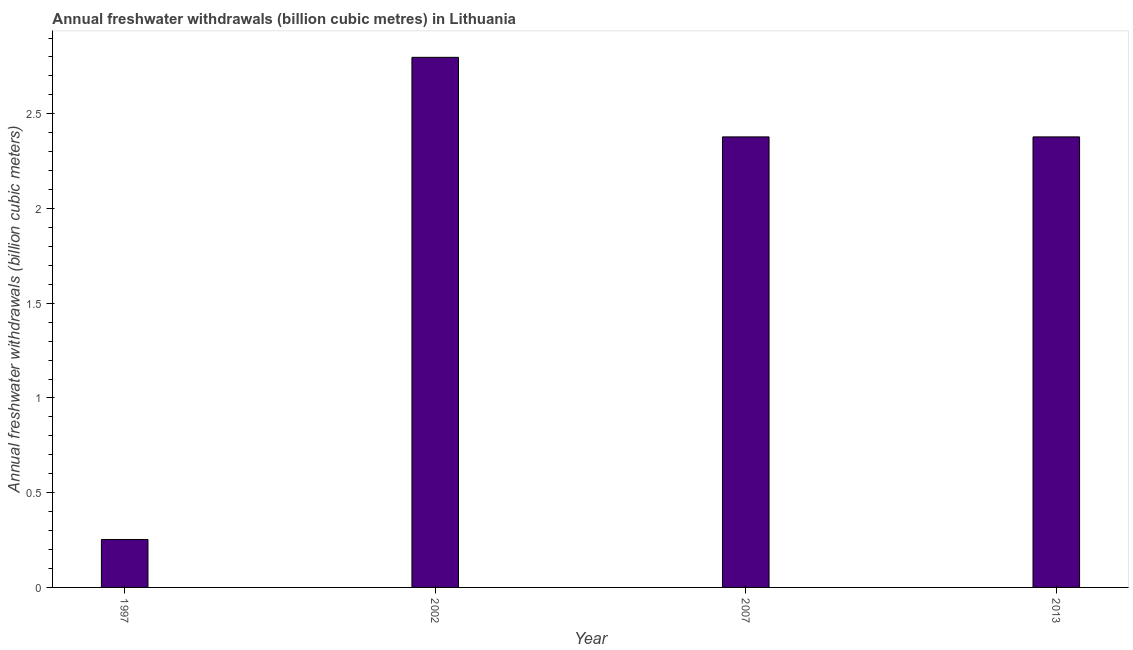Does the graph contain any zero values?
Keep it short and to the point. No. Does the graph contain grids?
Offer a terse response. No. What is the title of the graph?
Your answer should be very brief. Annual freshwater withdrawals (billion cubic metres) in Lithuania. What is the label or title of the X-axis?
Provide a succinct answer. Year. What is the label or title of the Y-axis?
Your response must be concise. Annual freshwater withdrawals (billion cubic meters). What is the annual freshwater withdrawals in 2002?
Provide a short and direct response. 2.8. Across all years, what is the maximum annual freshwater withdrawals?
Your response must be concise. 2.8. Across all years, what is the minimum annual freshwater withdrawals?
Ensure brevity in your answer.  0.25. What is the sum of the annual freshwater withdrawals?
Your answer should be very brief. 7.81. What is the difference between the annual freshwater withdrawals in 1997 and 2013?
Give a very brief answer. -2.12. What is the average annual freshwater withdrawals per year?
Make the answer very short. 1.95. What is the median annual freshwater withdrawals?
Your answer should be very brief. 2.38. In how many years, is the annual freshwater withdrawals greater than 2.8 billion cubic meters?
Make the answer very short. 0. What is the ratio of the annual freshwater withdrawals in 2002 to that in 2013?
Provide a succinct answer. 1.18. Is the difference between the annual freshwater withdrawals in 1997 and 2007 greater than the difference between any two years?
Your response must be concise. No. What is the difference between the highest and the second highest annual freshwater withdrawals?
Offer a terse response. 0.42. Is the sum of the annual freshwater withdrawals in 1997 and 2013 greater than the maximum annual freshwater withdrawals across all years?
Your answer should be compact. No. What is the difference between the highest and the lowest annual freshwater withdrawals?
Provide a short and direct response. 2.54. In how many years, is the annual freshwater withdrawals greater than the average annual freshwater withdrawals taken over all years?
Make the answer very short. 3. Are all the bars in the graph horizontal?
Make the answer very short. No. How many years are there in the graph?
Ensure brevity in your answer.  4. What is the difference between two consecutive major ticks on the Y-axis?
Your response must be concise. 0.5. What is the Annual freshwater withdrawals (billion cubic meters) in 1997?
Ensure brevity in your answer.  0.25. What is the Annual freshwater withdrawals (billion cubic meters) in 2002?
Provide a succinct answer. 2.8. What is the Annual freshwater withdrawals (billion cubic meters) of 2007?
Make the answer very short. 2.38. What is the Annual freshwater withdrawals (billion cubic meters) of 2013?
Offer a very short reply. 2.38. What is the difference between the Annual freshwater withdrawals (billion cubic meters) in 1997 and 2002?
Ensure brevity in your answer.  -2.54. What is the difference between the Annual freshwater withdrawals (billion cubic meters) in 1997 and 2007?
Provide a succinct answer. -2.12. What is the difference between the Annual freshwater withdrawals (billion cubic meters) in 1997 and 2013?
Give a very brief answer. -2.12. What is the difference between the Annual freshwater withdrawals (billion cubic meters) in 2002 and 2007?
Give a very brief answer. 0.42. What is the difference between the Annual freshwater withdrawals (billion cubic meters) in 2002 and 2013?
Offer a very short reply. 0.42. What is the difference between the Annual freshwater withdrawals (billion cubic meters) in 2007 and 2013?
Your answer should be very brief. 0. What is the ratio of the Annual freshwater withdrawals (billion cubic meters) in 1997 to that in 2002?
Your response must be concise. 0.09. What is the ratio of the Annual freshwater withdrawals (billion cubic meters) in 1997 to that in 2007?
Offer a terse response. 0.11. What is the ratio of the Annual freshwater withdrawals (billion cubic meters) in 1997 to that in 2013?
Provide a succinct answer. 0.11. What is the ratio of the Annual freshwater withdrawals (billion cubic meters) in 2002 to that in 2007?
Your answer should be compact. 1.18. What is the ratio of the Annual freshwater withdrawals (billion cubic meters) in 2002 to that in 2013?
Give a very brief answer. 1.18. What is the ratio of the Annual freshwater withdrawals (billion cubic meters) in 2007 to that in 2013?
Provide a succinct answer. 1. 